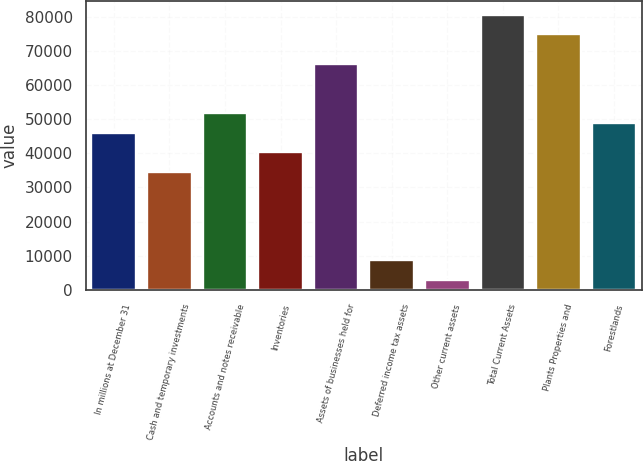Convert chart to OTSL. <chart><loc_0><loc_0><loc_500><loc_500><bar_chart><fcel>In millions at December 31<fcel>Cash and temporary investments<fcel>Accounts and notes receivable<fcel>Inventories<fcel>Assets of businesses held for<fcel>Deferred income tax assets<fcel>Other current assets<fcel>Total Current Assets<fcel>Plants Properties and<fcel>Forestlands<nl><fcel>46031.2<fcel>34524.4<fcel>51784.6<fcel>40277.8<fcel>66168.1<fcel>8634.1<fcel>2880.7<fcel>80551.6<fcel>74798.2<fcel>48907.9<nl></chart> 